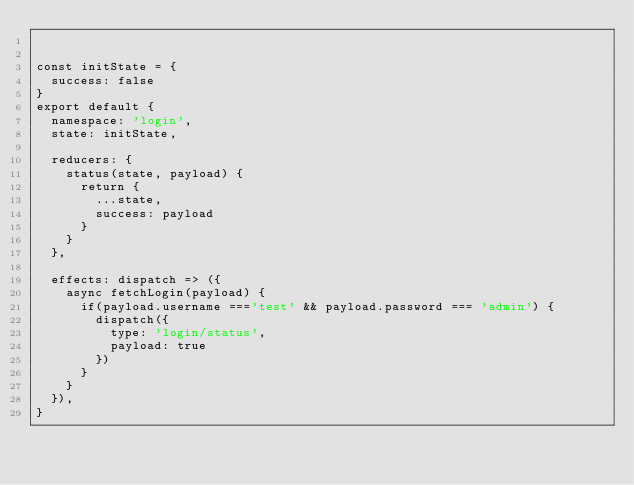<code> <loc_0><loc_0><loc_500><loc_500><_JavaScript_>

const initState = {
  success: false
}
export default {
  namespace: 'login',
  state: initState,

  reducers: {
    status(state, payload) {
      return {
        ...state,
        success: payload
      }
    }
  },

  effects: dispatch => ({
    async fetchLogin(payload) {
      if(payload.username ==='test' && payload.password === 'admin') {
        dispatch({
          type: 'login/status',
          payload: true
        })
      }
    }
  }),
}

</code> 